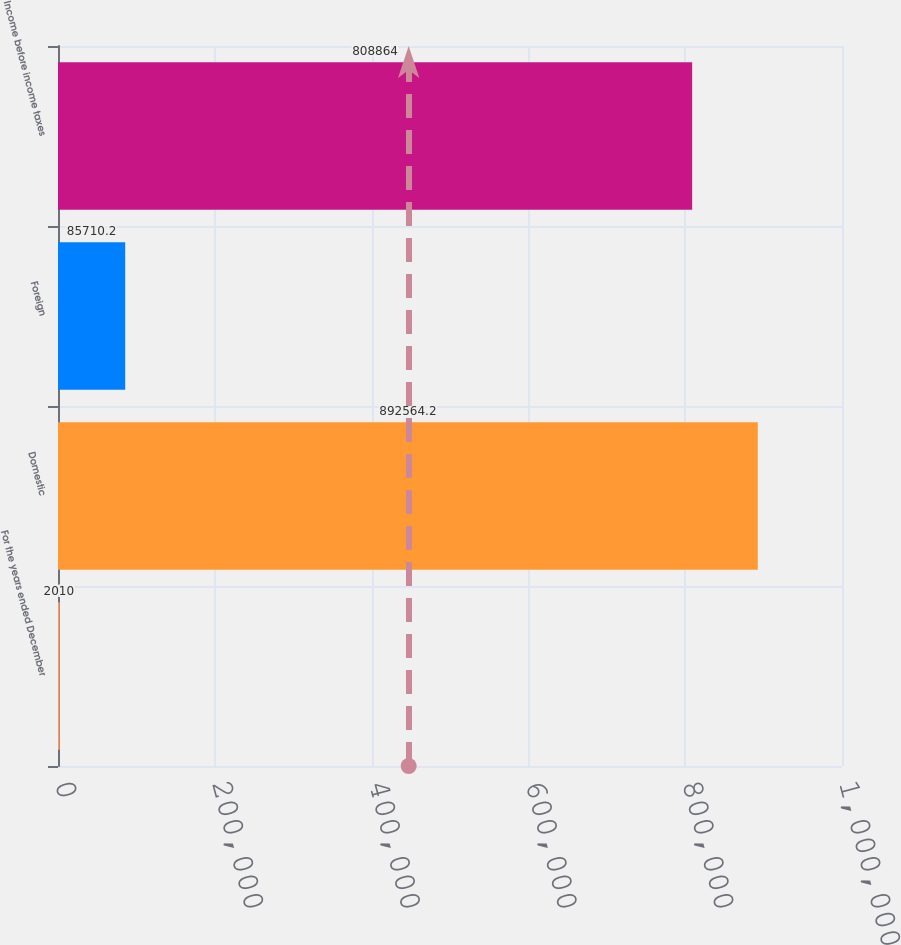<chart> <loc_0><loc_0><loc_500><loc_500><bar_chart><fcel>For the years ended December<fcel>Domestic<fcel>Foreign<fcel>Income before income taxes<nl><fcel>2010<fcel>892564<fcel>85710.2<fcel>808864<nl></chart> 